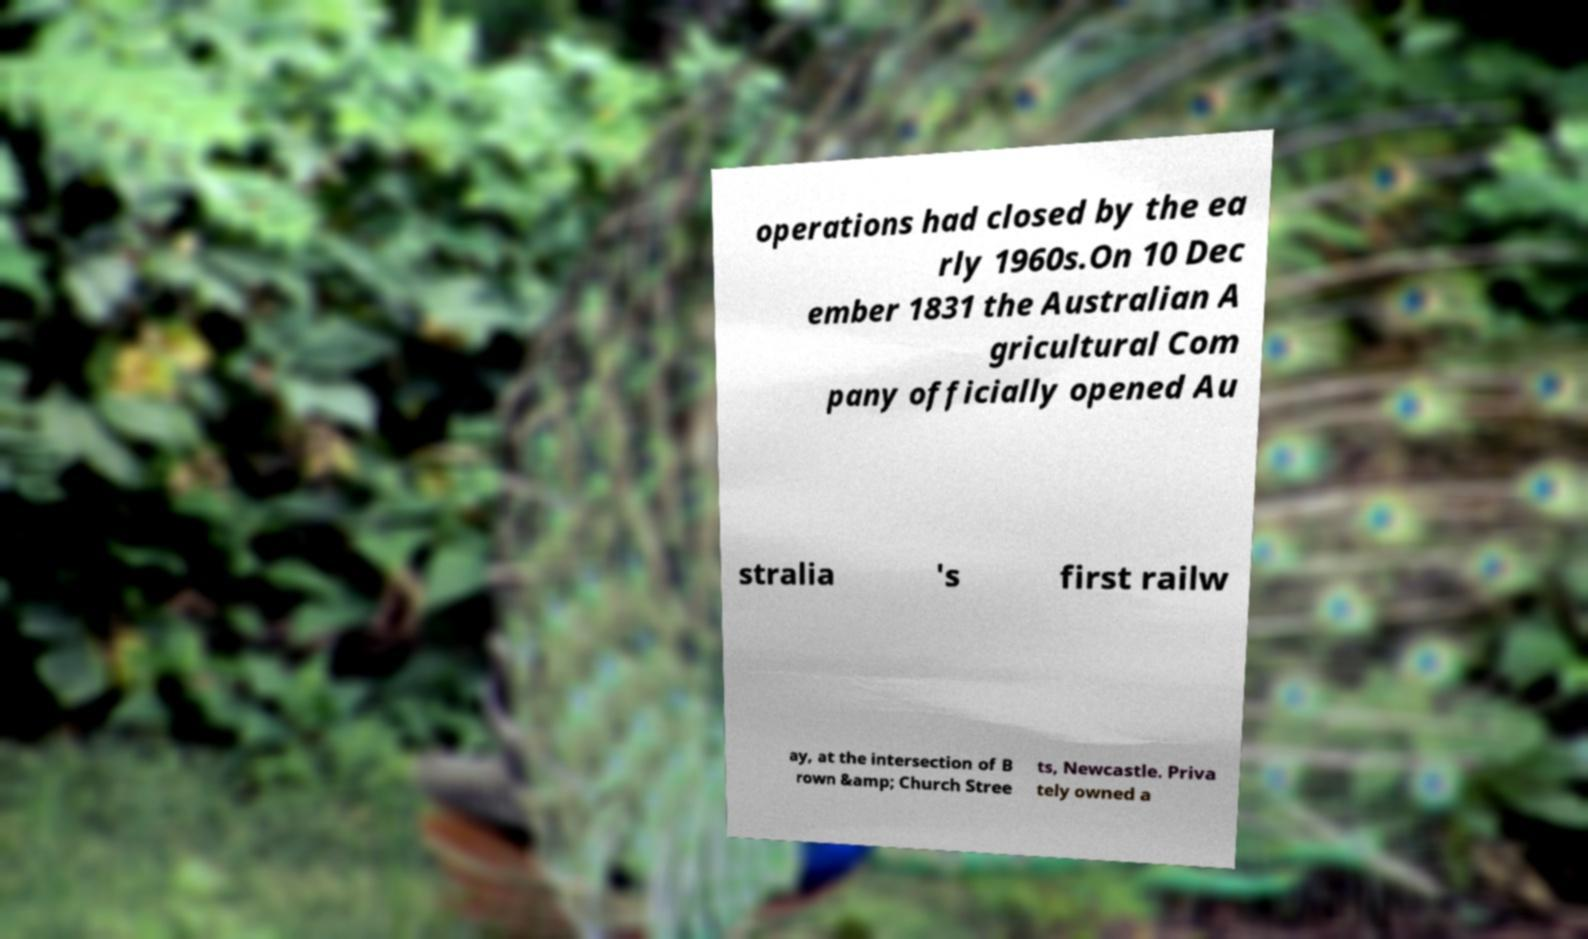Can you read and provide the text displayed in the image?This photo seems to have some interesting text. Can you extract and type it out for me? operations had closed by the ea rly 1960s.On 10 Dec ember 1831 the Australian A gricultural Com pany officially opened Au stralia 's first railw ay, at the intersection of B rown &amp; Church Stree ts, Newcastle. Priva tely owned a 